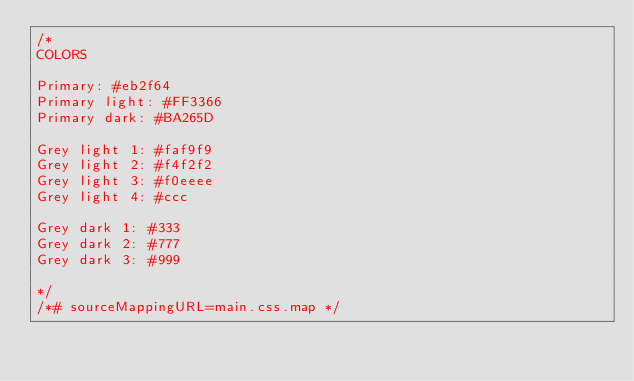Convert code to text. <code><loc_0><loc_0><loc_500><loc_500><_CSS_>/*
COLORS

Primary: #eb2f64
Primary light: #FF3366
Primary dark: #BA265D

Grey light 1: #faf9f9
Grey light 2: #f4f2f2
Grey light 3: #f0eeee
Grey light 4: #ccc

Grey dark 1: #333
Grey dark 2: #777
Grey dark 3: #999

*/
/*# sourceMappingURL=main.css.map */
</code> 